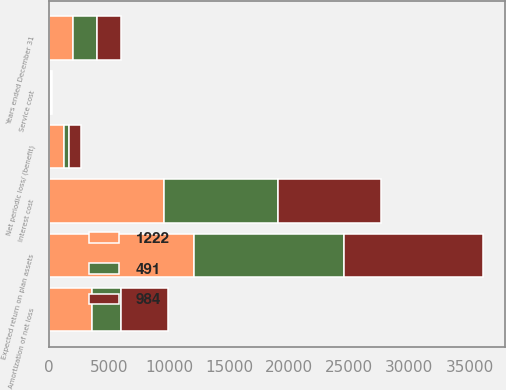Convert chart to OTSL. <chart><loc_0><loc_0><loc_500><loc_500><stacked_bar_chart><ecel><fcel>Years ended December 31<fcel>Service cost<fcel>Interest cost<fcel>Expected return on plan assets<fcel>Amortization of net loss<fcel>Net periodic loss/ (benefit)<nl><fcel>491<fcel>2014<fcel>74<fcel>9427<fcel>12431<fcel>2439<fcel>491<nl><fcel>984<fcel>2013<fcel>112<fcel>8551<fcel>11589<fcel>3910<fcel>984<nl><fcel>1222<fcel>2012<fcel>100<fcel>9622<fcel>12106<fcel>3606<fcel>1222<nl></chart> 